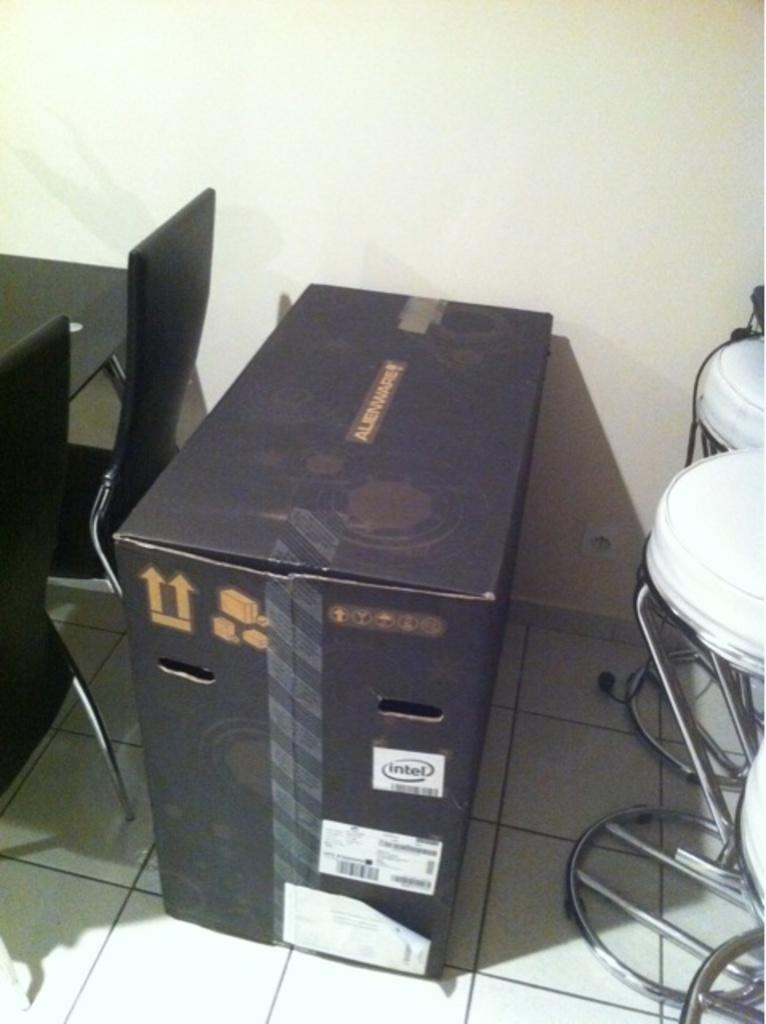What object is present in the image that is typically used for storage or packaging? There is a cardboard box in the image. What can be found on the cardboard box? There is text on the cardboard box. What type of furniture is visible in the image? There are chairs and a table in the image. What part of the room can be seen at the bottom of the image? The floor is visible at the bottom of the image. What part of the room can be seen at the back of the image? There is a wall visible at the back of the image. How many gloves are placed on the table in the image? There are no gloves present in the image. What type of cup is being used to measure the liquid on the table? There is no cup present in the image. 